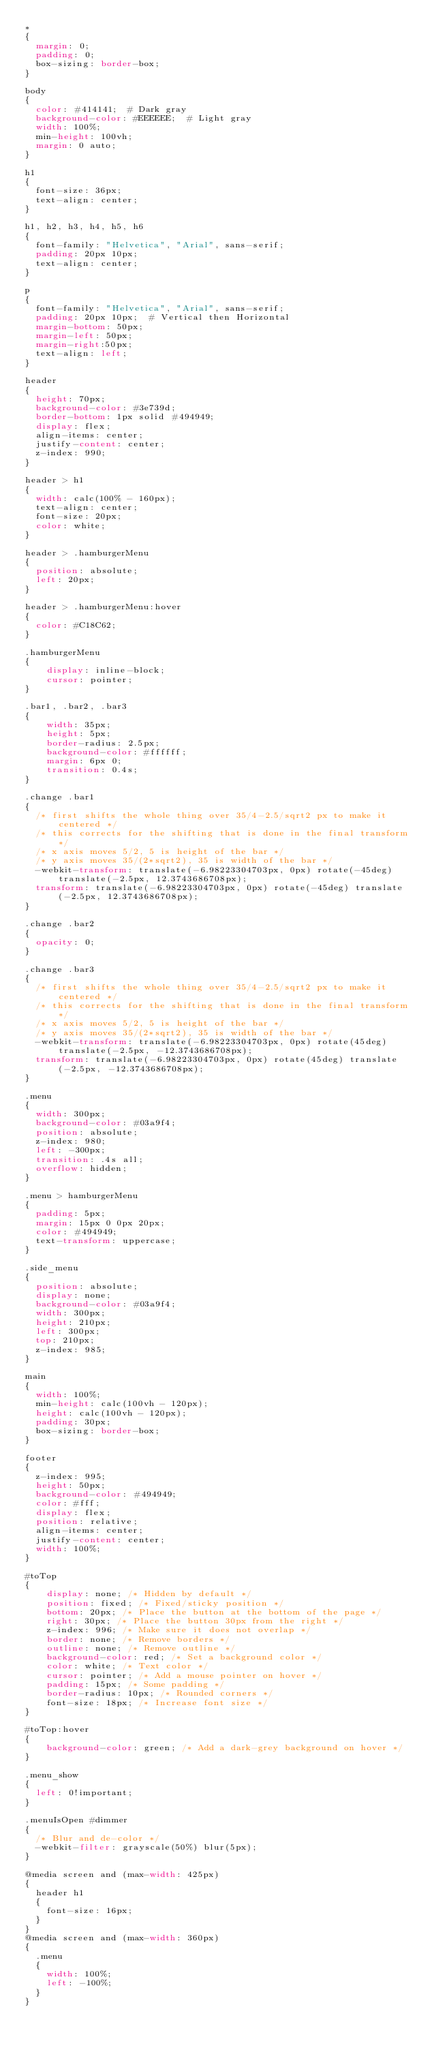Convert code to text. <code><loc_0><loc_0><loc_500><loc_500><_CSS_>*
{
  margin: 0;
  padding: 0;
  box-sizing: border-box;
}

body
{
  color: #414141;  # Dark gray
  background-color: #EEEEEE;  # Light gray
  width: 100%;
  min-height: 100vh;
  margin: 0 auto;
}

h1
{
  font-size: 36px;
  text-align: center;
}

h1, h2, h3, h4, h5, h6
{
  font-family: "Helvetica", "Arial", sans-serif;
  padding: 20px 10px;
  text-align: center;
}

p
{
  font-family: "Helvetica", "Arial", sans-serif;
  padding: 20px 10px;  # Vertical then Horizontal
  margin-bottom: 50px;
  margin-left: 50px;
  margin-right:50px;
  text-align: left;
}

header
{
	height: 70px;
	background-color: #3e739d;
	border-bottom: 1px solid #494949;
	display: flex;
	align-items: center;
	justify-content: center;
  z-index: 990;
}

header > h1
{
	width: calc(100% - 160px);
	text-align: center;
	font-size: 20px;
	color: white;
}

header > .hamburgerMenu
{
	position: absolute;
	left: 20px;
}

header > .hamburgerMenu:hover
{
	color: #C18C62;
}

.hamburgerMenu
{
    display: inline-block;
    cursor: pointer;
}

.bar1, .bar2, .bar3
{
    width: 35px;
    height: 5px;
    border-radius: 2.5px;
    background-color: #ffffff;
    margin: 6px 0;
    transition: 0.4s;
}

.change .bar1
{
  /* first shifts the whole thing over 35/4-2.5/sqrt2 px to make it centered */
  /* this corrects for the shifting that is done in the final transform */
  /* x axis moves 5/2, 5 is height of the bar */
  /* y axis moves 35/(2*sqrt2), 35 is width of the bar */
  -webkit-transform: translate(-6.98223304703px, 0px) rotate(-45deg) translate(-2.5px, 12.3743686708px);
  transform: translate(-6.98223304703px, 0px) rotate(-45deg) translate(-2.5px, 12.3743686708px);
}

.change .bar2
{
  opacity: 0;
}

.change .bar3
{
  /* first shifts the whole thing over 35/4-2.5/sqrt2 px to make it centered */
  /* this corrects for the shifting that is done in the final transform */
  /* x axis moves 5/2, 5 is height of the bar */
  /* y axis moves 35/(2*sqrt2), 35 is width of the bar */
  -webkit-transform: translate(-6.98223304703px, 0px) rotate(45deg) translate(-2.5px, -12.3743686708px);
  transform: translate(-6.98223304703px, 0px) rotate(45deg) translate(-2.5px, -12.3743686708px);
}

.menu
{
	width: 300px;
	background-color: #03a9f4;
  position: absolute;
  z-index: 980;
	left: -300px;
	transition: .4s all;
  overflow: hidden;
}

.menu > hamburgerMenu
{
  padding: 5px;
  margin: 15px 0 0px 20px;
  color: #494949;
  text-transform: uppercase;
}

.side_menu
{
  position: absolute;
  display: none;
  background-color: #03a9f4;
  width: 300px;
  height: 210px;
  left: 300px;
  top: 210px;
  z-index: 985;
}

main
{
	width: 100%;
  min-height: calc(100vh - 120px);
  height: calc(100vh - 120px);
	padding: 30px;
	box-sizing: border-box;
}

footer
{
  z-index: 995;
	height: 50px;
	background-color: #494949;
	color: #fff;
	display: flex;
  position: relative;
	align-items: center;
	justify-content: center;
	width: 100%;
}

#toTop
{
    display: none; /* Hidden by default */
    position: fixed; /* Fixed/sticky position */
    bottom: 20px; /* Place the button at the bottom of the page */
    right: 30px; /* Place the button 30px from the right */
    z-index: 996; /* Make sure it does not overlap */
    border: none; /* Remove borders */
    outline: none; /* Remove outline */
    background-color: red; /* Set a background color */
    color: white; /* Text color */
    cursor: pointer; /* Add a mouse pointer on hover */
    padding: 15px; /* Some padding */
    border-radius: 10px; /* Rounded corners */
    font-size: 18px; /* Increase font size */
}

#toTop:hover
{
    background-color: green; /* Add a dark-grey background on hover */
}

.menu_show
{
	left: 0!important;
}

.menuIsOpen #dimmer
{
  /* Blur and de-color */
  -webkit-filter: grayscale(50%) blur(5px);
}

@media screen and (max-width: 425px)
{
	header h1
  {
		font-size: 16px;
	}
}
@media screen and (max-width: 360px)
{
	.menu
  {
		width: 100%;
		left: -100%;
	}
}
</code> 